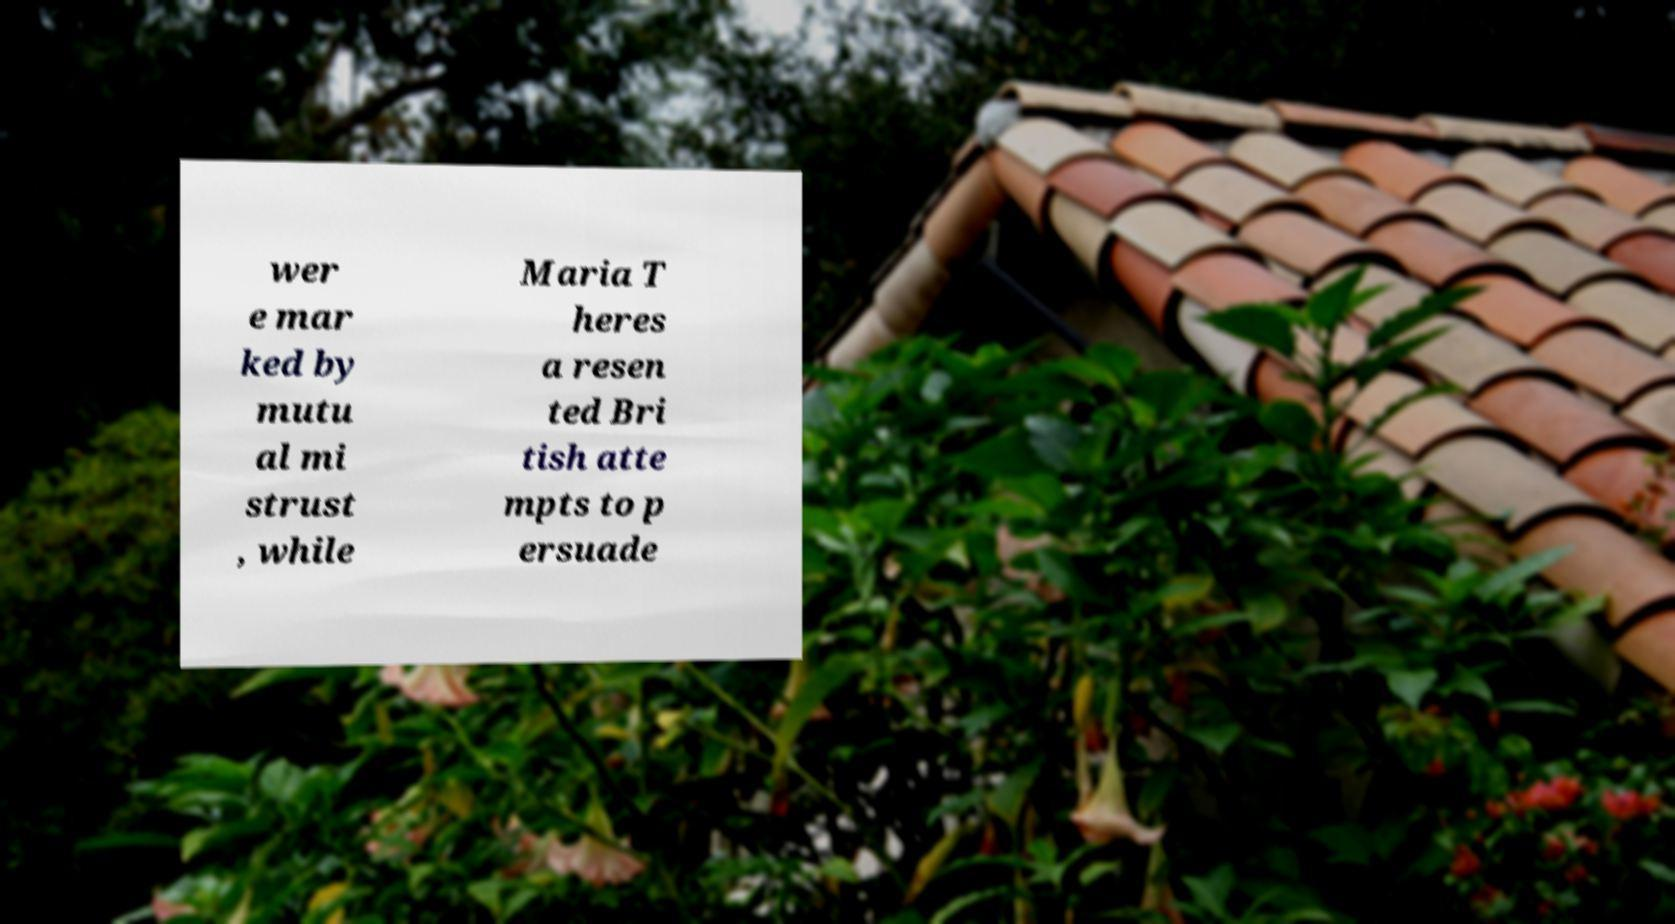For documentation purposes, I need the text within this image transcribed. Could you provide that? wer e mar ked by mutu al mi strust , while Maria T heres a resen ted Bri tish atte mpts to p ersuade 